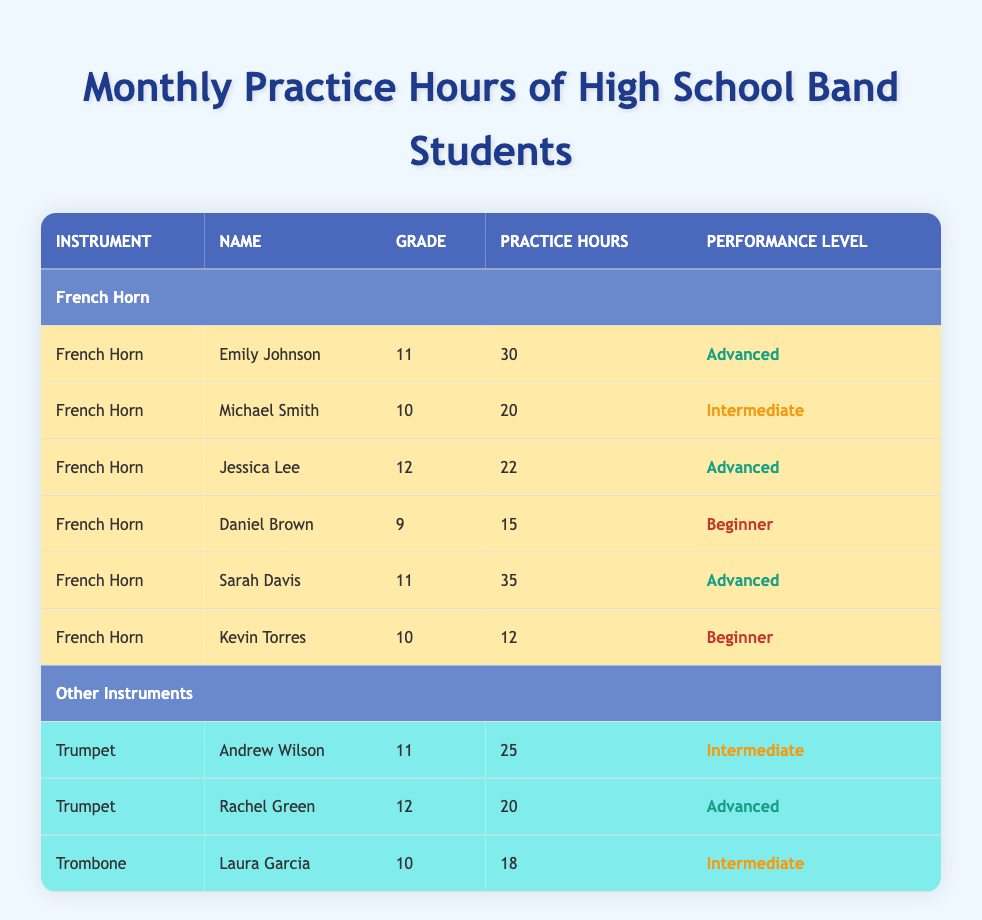What is the name of the student with the most practice hours on the French horn? To find the student with the most practice hours, I look at the "Practice Hours" column under the French Horn section. Emily Johnson has 30 hours, Sarah Davis has 35 hours, Jessica Lee has 22 hours, Michael Smith has 20 hours, Daniel Brown has 15 hours, and Kevin Torres has 12 hours. Sarah Davis has the highest number of practice hours.
Answer: Sarah Davis How many students are listed for the French horn? I count the number of rows under the French Horn section. There are 6 students listed: Emily Johnson, Michael Smith, Jessica Lee, Daniel Brown, Sarah Davis, and Kevin Torres.
Answer: 6 What is the average practice hours of French horn students? To calculate the average, I sum the practice hours: 30 + 20 + 22 + 15 + 35 + 12 = 134 hours. There are 6 students, so I divide 134 by 6, which gives an average of approximately 22.33 hours.
Answer: 22.33 Is there a student in the French horn section at a beginner performance level? I look through the performance levels of the students in the French horn section. Daniel Brown is labeled as a beginner, and Kevin Torres is also labeled as a beginner. Thus, yes, there are students at the beginner level.
Answer: Yes How many students practice more than 25 hours on the French horn? I check the practice hours of each student. Emily Johnson practices for 30 hours, Sarah Davis practices for 35 hours (both above 25), while Michael Smith (20), Jessica Lee (22), Daniel Brown (15), and Kevin Torres (12) practice fewer hours. Only Emily Johnson and Sarah Davis practice more than 25 hours.
Answer: 2 Which grade has the most representation among French horn players? I look at the grade column for the French horn students. The breakdown is as follows: Grade 9 – 1 student (Daniel Brown), Grade 10 – 2 students (Michael Smith, Kevin Torres), Grade 11 – 2 students (Emily Johnson, Sarah Davis), and Grade 12 – 1 student (Jessica Lee). Grades 10 and 11 each have the most representation with 2 students.
Answer: Grades 10 and 11 Which student has the least practice hours on the French horn? I scan the practice hours to find the lowest value. The practice hours are: 30, 20, 22, 15, 35, and 12. Kevin Torres, with 12 hours, has the least.
Answer: Kevin Torres Is Sarah Davis in the 11th grade? I can find Sarah Davis in the French horn section under "Grade." She is listed as being in 11th grade.
Answer: Yes What is the total practice hours of all French horn students combined? I sum the practice hours for each student: 30 + 20 + 22 + 15 + 35 + 12. Adding these gives a total of 134 hours for all students combined.
Answer: 134 